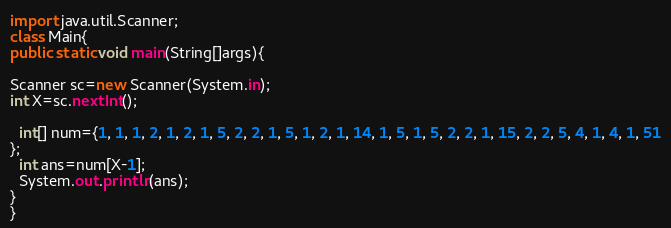<code> <loc_0><loc_0><loc_500><loc_500><_Java_>import java.util.Scanner;
class Main{
public static void main(String[]args){

Scanner sc=new Scanner(System.in);
int X=sc.nextInt();

  int[] num={1, 1, 1, 2, 1, 2, 1, 5, 2, 2, 1, 5, 1, 2, 1, 14, 1, 5, 1, 5, 2, 2, 1, 15, 2, 2, 5, 4, 1, 4, 1, 51
};
  int ans=num[X-1];
  System.out.println(ans);
}
}</code> 